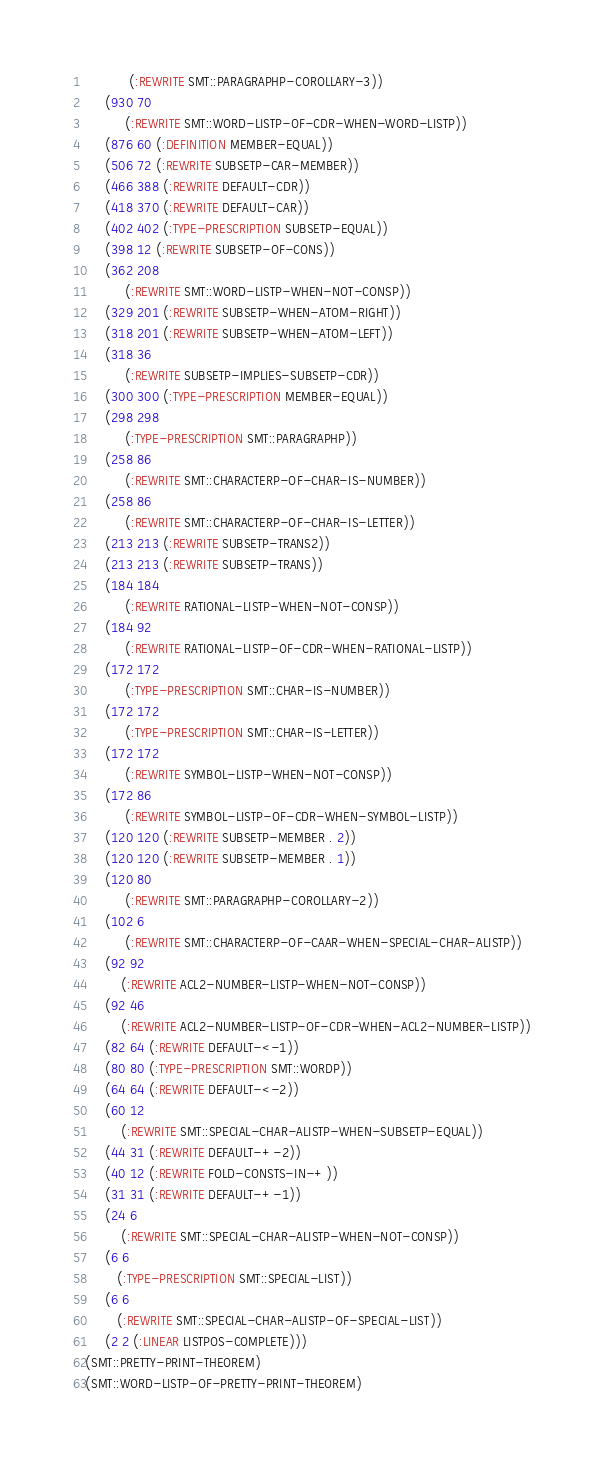<code> <loc_0><loc_0><loc_500><loc_500><_Lisp_>           (:REWRITE SMT::PARAGRAPHP-COROLLARY-3))
     (930 70
          (:REWRITE SMT::WORD-LISTP-OF-CDR-WHEN-WORD-LISTP))
     (876 60 (:DEFINITION MEMBER-EQUAL))
     (506 72 (:REWRITE SUBSETP-CAR-MEMBER))
     (466 388 (:REWRITE DEFAULT-CDR))
     (418 370 (:REWRITE DEFAULT-CAR))
     (402 402 (:TYPE-PRESCRIPTION SUBSETP-EQUAL))
     (398 12 (:REWRITE SUBSETP-OF-CONS))
     (362 208
          (:REWRITE SMT::WORD-LISTP-WHEN-NOT-CONSP))
     (329 201 (:REWRITE SUBSETP-WHEN-ATOM-RIGHT))
     (318 201 (:REWRITE SUBSETP-WHEN-ATOM-LEFT))
     (318 36
          (:REWRITE SUBSETP-IMPLIES-SUBSETP-CDR))
     (300 300 (:TYPE-PRESCRIPTION MEMBER-EQUAL))
     (298 298
          (:TYPE-PRESCRIPTION SMT::PARAGRAPHP))
     (258 86
          (:REWRITE SMT::CHARACTERP-OF-CHAR-IS-NUMBER))
     (258 86
          (:REWRITE SMT::CHARACTERP-OF-CHAR-IS-LETTER))
     (213 213 (:REWRITE SUBSETP-TRANS2))
     (213 213 (:REWRITE SUBSETP-TRANS))
     (184 184
          (:REWRITE RATIONAL-LISTP-WHEN-NOT-CONSP))
     (184 92
          (:REWRITE RATIONAL-LISTP-OF-CDR-WHEN-RATIONAL-LISTP))
     (172 172
          (:TYPE-PRESCRIPTION SMT::CHAR-IS-NUMBER))
     (172 172
          (:TYPE-PRESCRIPTION SMT::CHAR-IS-LETTER))
     (172 172
          (:REWRITE SYMBOL-LISTP-WHEN-NOT-CONSP))
     (172 86
          (:REWRITE SYMBOL-LISTP-OF-CDR-WHEN-SYMBOL-LISTP))
     (120 120 (:REWRITE SUBSETP-MEMBER . 2))
     (120 120 (:REWRITE SUBSETP-MEMBER . 1))
     (120 80
          (:REWRITE SMT::PARAGRAPHP-COROLLARY-2))
     (102 6
          (:REWRITE SMT::CHARACTERP-OF-CAAR-WHEN-SPECIAL-CHAR-ALISTP))
     (92 92
         (:REWRITE ACL2-NUMBER-LISTP-WHEN-NOT-CONSP))
     (92 46
         (:REWRITE ACL2-NUMBER-LISTP-OF-CDR-WHEN-ACL2-NUMBER-LISTP))
     (82 64 (:REWRITE DEFAULT-<-1))
     (80 80 (:TYPE-PRESCRIPTION SMT::WORDP))
     (64 64 (:REWRITE DEFAULT-<-2))
     (60 12
         (:REWRITE SMT::SPECIAL-CHAR-ALISTP-WHEN-SUBSETP-EQUAL))
     (44 31 (:REWRITE DEFAULT-+-2))
     (40 12 (:REWRITE FOLD-CONSTS-IN-+))
     (31 31 (:REWRITE DEFAULT-+-1))
     (24 6
         (:REWRITE SMT::SPECIAL-CHAR-ALISTP-WHEN-NOT-CONSP))
     (6 6
        (:TYPE-PRESCRIPTION SMT::SPECIAL-LIST))
     (6 6
        (:REWRITE SMT::SPECIAL-CHAR-ALISTP-OF-SPECIAL-LIST))
     (2 2 (:LINEAR LISTPOS-COMPLETE)))
(SMT::PRETTY-PRINT-THEOREM)
(SMT::WORD-LISTP-OF-PRETTY-PRINT-THEOREM)
</code> 